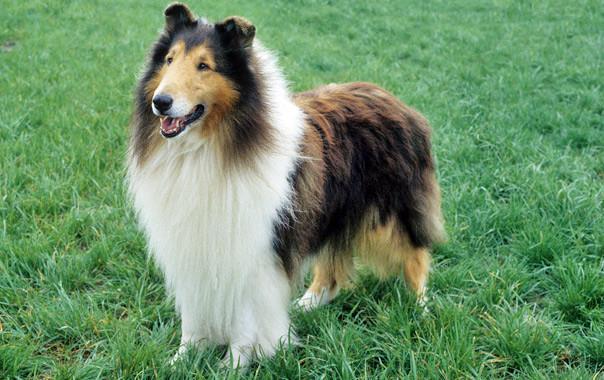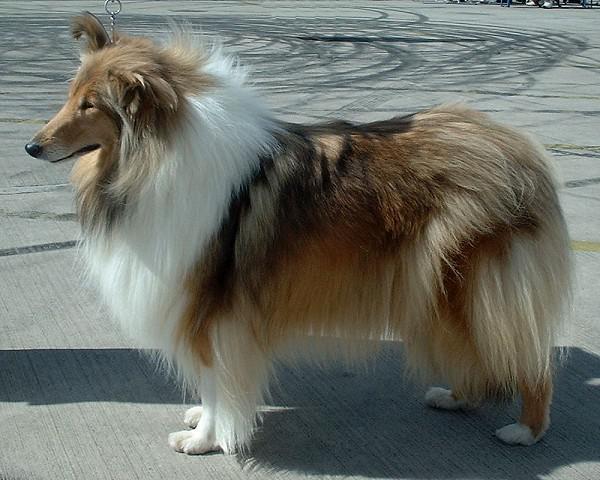The first image is the image on the left, the second image is the image on the right. Examine the images to the left and right. Is the description "One image shows a collie standing on grass, and the other is a portrait." accurate? Answer yes or no. No. 